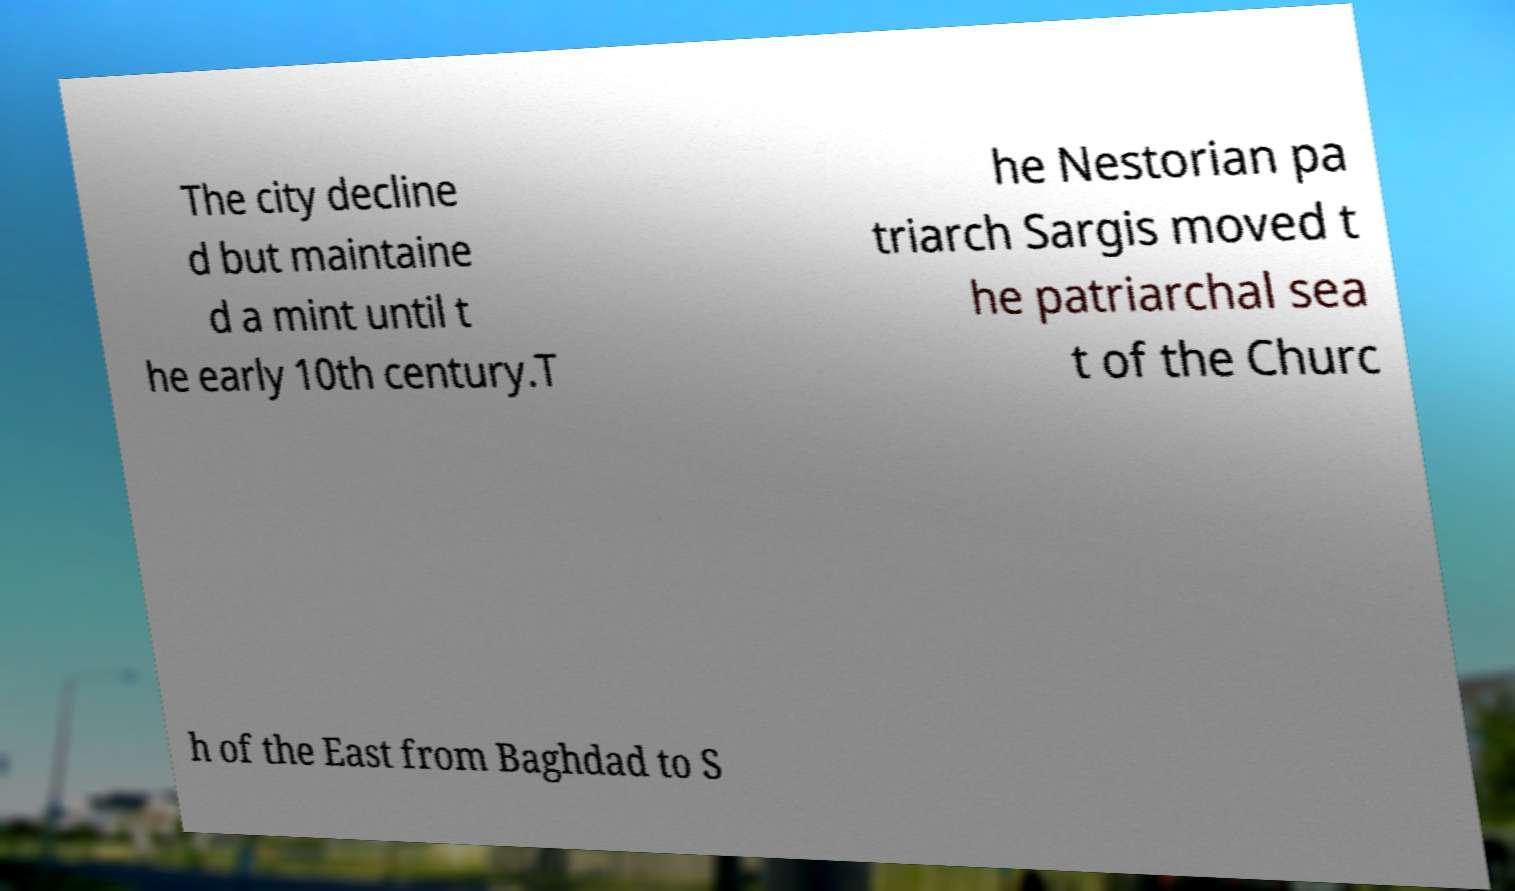For documentation purposes, I need the text within this image transcribed. Could you provide that? The city decline d but maintaine d a mint until t he early 10th century.T he Nestorian pa triarch Sargis moved t he patriarchal sea t of the Churc h of the East from Baghdad to S 